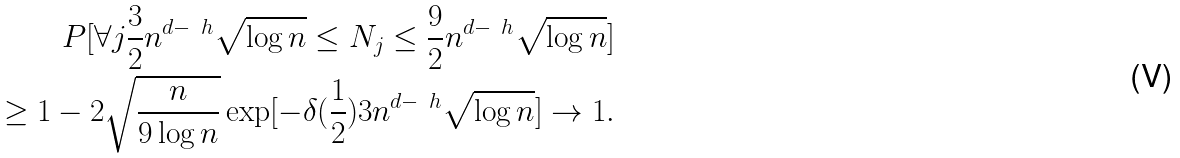<formula> <loc_0><loc_0><loc_500><loc_500>P [ \forall j \frac { 3 } { 2 } n ^ { d - \ h } \sqrt { \log n } \leq N _ { j } \leq \frac { 9 } { 2 } n ^ { d - \ h } \sqrt { \log n } ] \\ \geq 1 - 2 \sqrt { \frac { n } { 9 \log n } } \exp [ - \delta ( \frac { 1 } { 2 } ) 3 n ^ { d - \ h } \sqrt { \log n } ] \rightarrow 1 .</formula> 